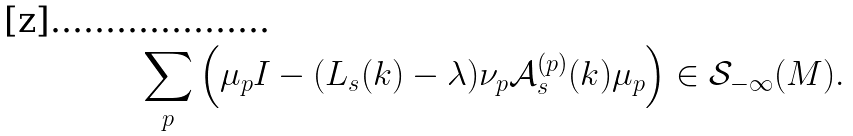<formula> <loc_0><loc_0><loc_500><loc_500>\sum _ { p } \left ( \mu _ { p } I - ( L _ { s } ( k ) - \lambda ) \nu _ { p } \mathcal { A } ^ { ( p ) } _ { s } ( k ) \mu _ { p } \right ) \in \mathcal { S } _ { - \infty } ( M ) .</formula> 